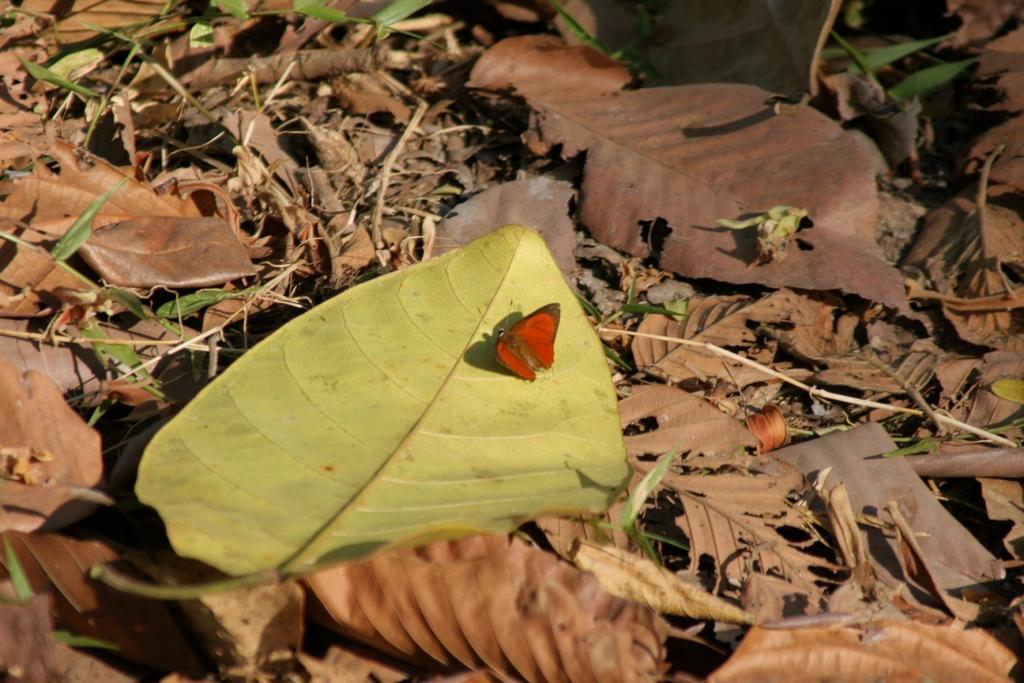How would you summarize this image in a sentence or two? In this picture I can see the leaves on the ground and I can see a butterfly in center of this picture and I see that it is of red color. 